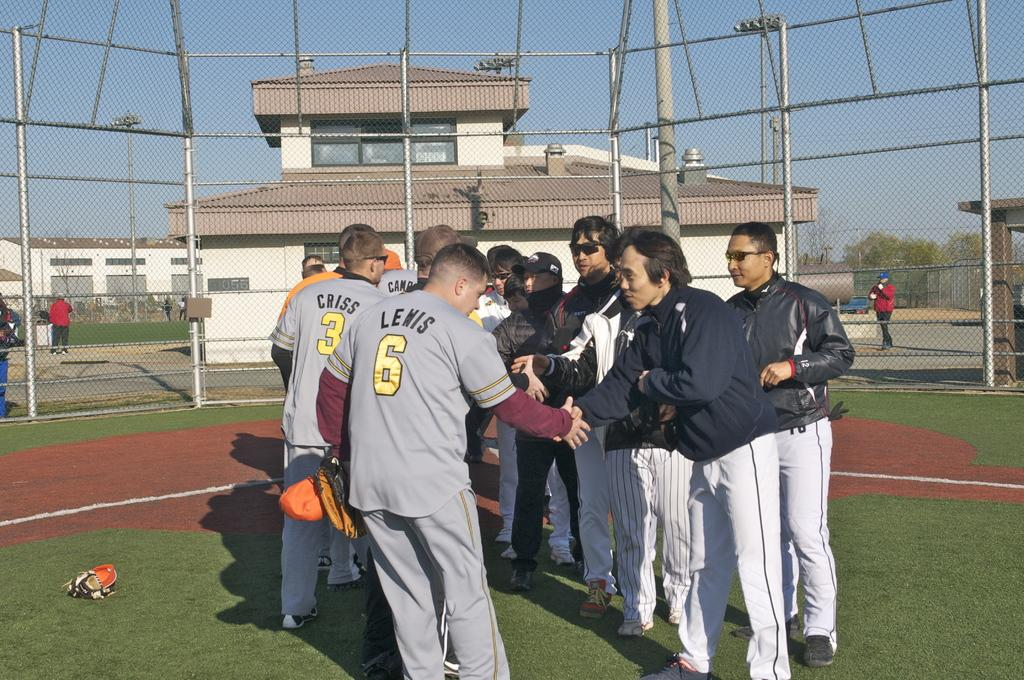<image>
Describe the image concisely. Number 6 Lewis shakes hands with other players on the field/ 